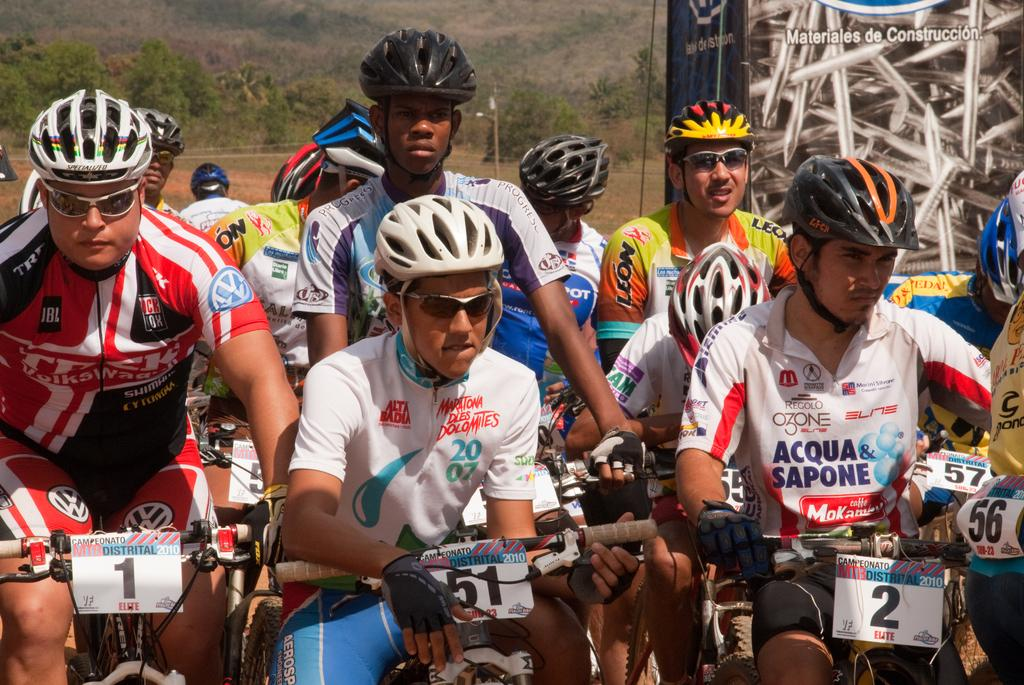What are the persons in the image doing? The persons in the image are sitting on bicycles. What safety precaution are the persons taking in the image? The persons are wearing helmets on their heads. What can be seen in the background of the image? There is a banner and objects on a pole in the background of the image, as well as trees. What type of gun is the authority figure holding in the image? There is no authority figure or gun present in the image. What kind of paper is being used to write the message on the banner in the image? The image does not provide information about the type of paper used for the banner. 